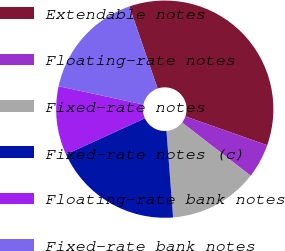Convert chart to OTSL. <chart><loc_0><loc_0><loc_500><loc_500><pie_chart><fcel>Extendable notes<fcel>Floating-rate notes<fcel>Fixed-rate notes<fcel>Fixed-rate notes (c)<fcel>Floating-rate bank notes<fcel>Fixed-rate bank notes<nl><fcel>35.67%<fcel>5.11%<fcel>13.28%<fcel>19.39%<fcel>10.22%<fcel>16.33%<nl></chart> 